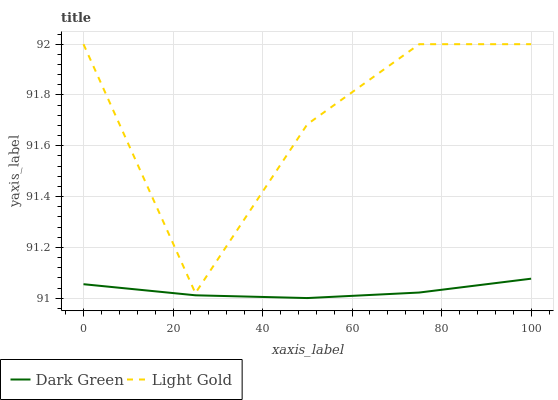Does Dark Green have the maximum area under the curve?
Answer yes or no. No. Is Dark Green the roughest?
Answer yes or no. No. Does Dark Green have the highest value?
Answer yes or no. No. Is Dark Green less than Light Gold?
Answer yes or no. Yes. Is Light Gold greater than Dark Green?
Answer yes or no. Yes. Does Dark Green intersect Light Gold?
Answer yes or no. No. 